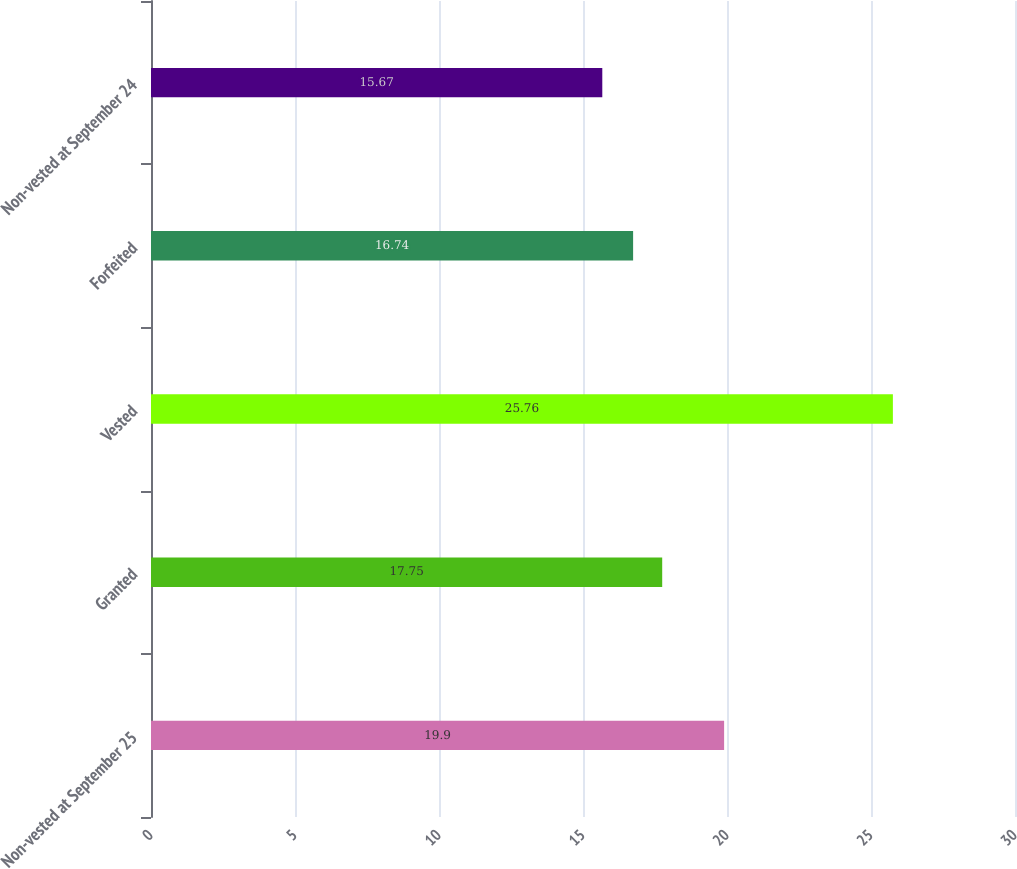Convert chart. <chart><loc_0><loc_0><loc_500><loc_500><bar_chart><fcel>Non-vested at September 25<fcel>Granted<fcel>Vested<fcel>Forfeited<fcel>Non-vested at September 24<nl><fcel>19.9<fcel>17.75<fcel>25.76<fcel>16.74<fcel>15.67<nl></chart> 